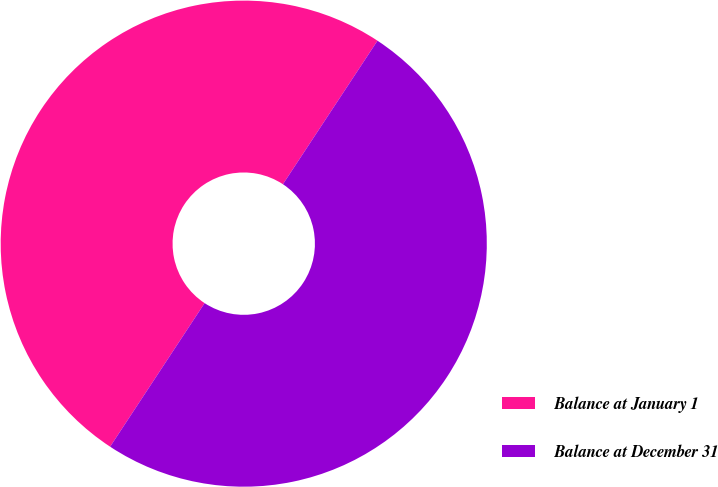Convert chart to OTSL. <chart><loc_0><loc_0><loc_500><loc_500><pie_chart><fcel>Balance at January 1<fcel>Balance at December 31<nl><fcel>50.01%<fcel>49.99%<nl></chart> 